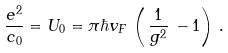Convert formula to latex. <formula><loc_0><loc_0><loc_500><loc_500>\frac { e ^ { 2 } } { c _ { 0 } } = U _ { 0 } = \pi \hbar { v } _ { F } \, \left ( \, \frac { 1 } { g ^ { 2 } } \, - 1 \right ) \, .</formula> 